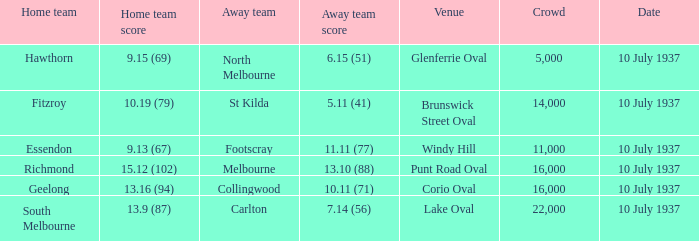What was the lowest Crowd during the Away Team Score of 10.11 (71)? 16000.0. 